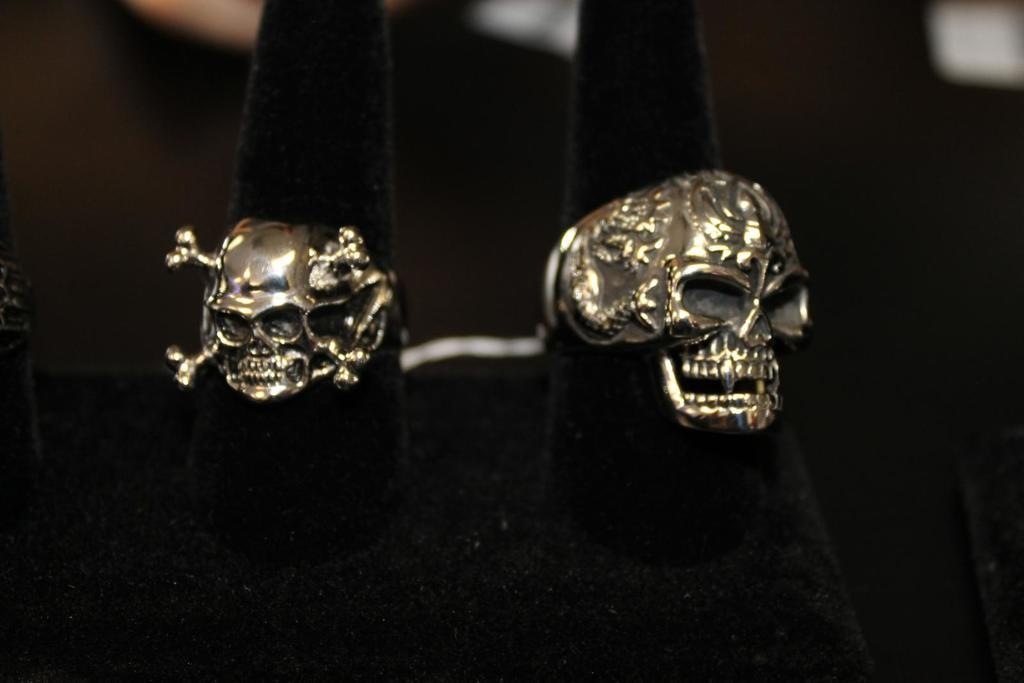What type of objects are made with metal in the image? There are two skulls made with metal in the image. What is the color of the black object in the image? The black object in the image is black. How would you describe the background of the image? The background of the image is blurred. What is the digestion process of the skulls in the image? The skulls in the image are made of metal and do not have a digestion process. 